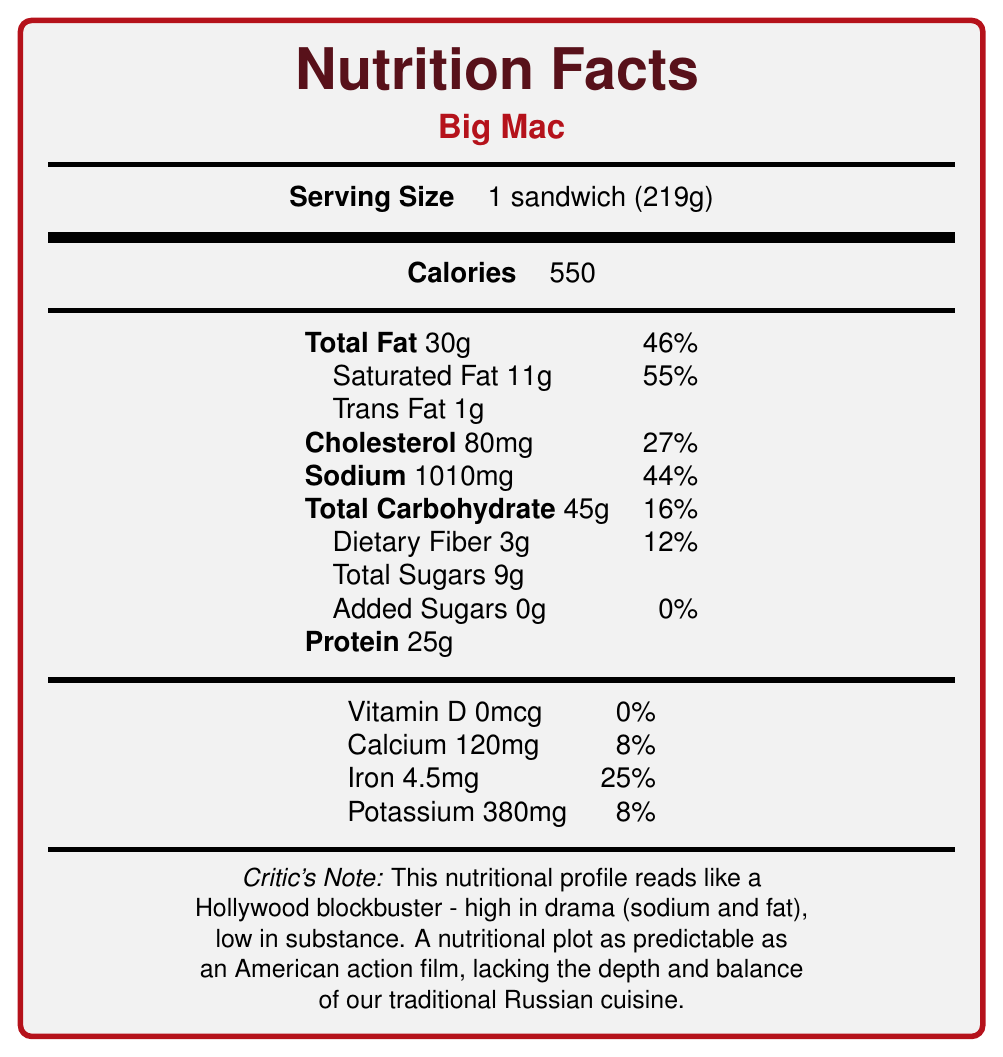What is the serving size of the Big Mac? The document explicitly states the serving size as "1 sandwich (219g)" under the product name.
Answer: 1 sandwich (219g) How many calories does a Big Mac contain? The calories are listed directly after the serving size in the document.
Answer: 550 What percentage of the daily value is provided by the saturated fat in one Big Mac? The saturated fat amount and its daily value percentage are clearly specified as 11g and 55%, respectively.
Answer: 55% How much sodium does a Big Mac have, and what is its daily value percentage? The sodium content is listed as 1010mg, which is 44% of the daily recommended value.
Answer: 1010mg, 44% What is the amount of protein in a Big Mac? The protein amount is listed as 25g in the document.
Answer: 25g Which vitamin or mineral has the highest daily value percentage in a Big Mac? A. Vitamin D B. Calcium C. Iron D. Potassium The minerals are listed with their daily values, showing Iron (25%) has the highest percentage.
Answer: C. Iron How much dietary fiber is in a Big Mac? The document lists dietary fiber as part of the total carbohydrate breakdown, amounting to 3g.
Answer: 3g Is there any added sugar in a Big Mac? Added sugars are listed as 0g, which means there are no added sugars in the burger.
Answer: No Does the document compare the nutritional profile of a Big Mac to any cuisine? The document compares the nutritional profile to traditional Russian cuisine, highlighting differences in nutrient incorporation.
Answer: Yes Can you determine the cost of a Big Mac based on this document? The document does not provide any information about the cost of a Big Mac.
Answer: No What is the critic's main idea about the nutritional content of the Big Mac? The critic's note at the end of the document summarizes that the nutritional profile is high in drama (sodium and fat) and low in substance, and compares it unfavorably to traditional Russian cuisine which is described as having a wider range of nutrients.
Answer: The Big Mac lacks nutritional balance, with high levels of sodium and saturated fat, and is compared unfavorably to traditional Russian cuisine. 